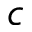<formula> <loc_0><loc_0><loc_500><loc_500>c</formula> 